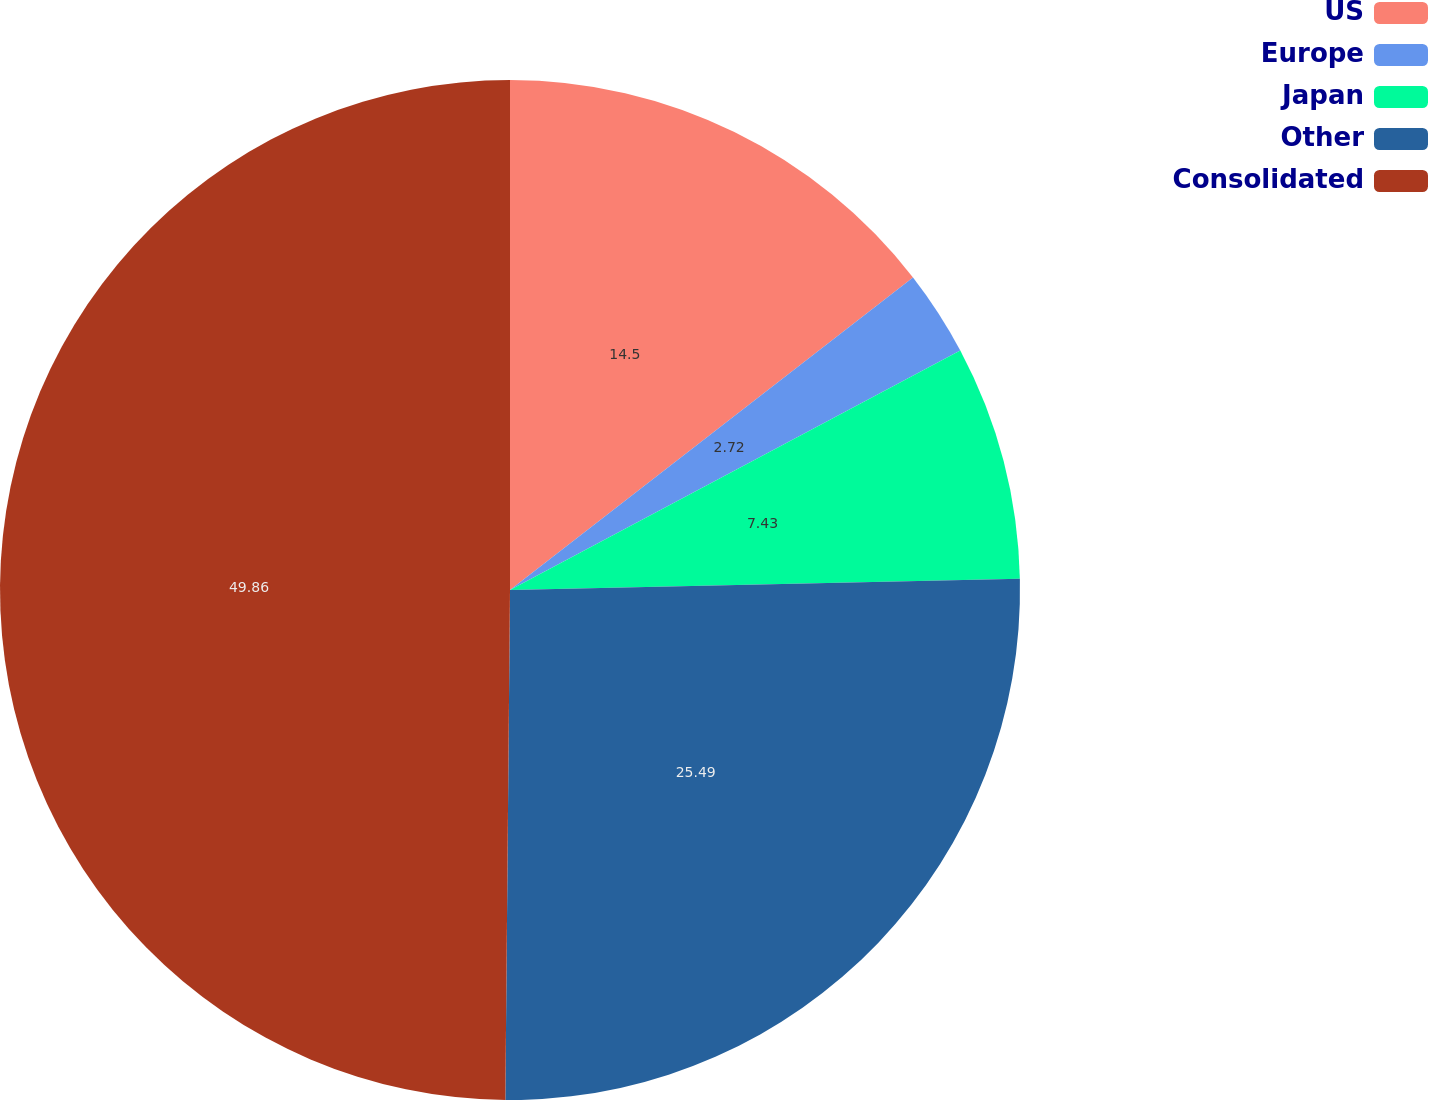Convert chart. <chart><loc_0><loc_0><loc_500><loc_500><pie_chart><fcel>US<fcel>Europe<fcel>Japan<fcel>Other<fcel>Consolidated<nl><fcel>14.5%<fcel>2.72%<fcel>7.43%<fcel>25.49%<fcel>49.85%<nl></chart> 